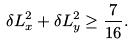Convert formula to latex. <formula><loc_0><loc_0><loc_500><loc_500>\delta L _ { x } ^ { 2 } + \delta L _ { y } ^ { 2 } \geq \frac { 7 } { 1 6 } .</formula> 